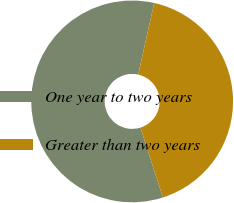<chart> <loc_0><loc_0><loc_500><loc_500><pie_chart><fcel>One year to two years<fcel>Greater than two years<nl><fcel>58.42%<fcel>41.58%<nl></chart> 